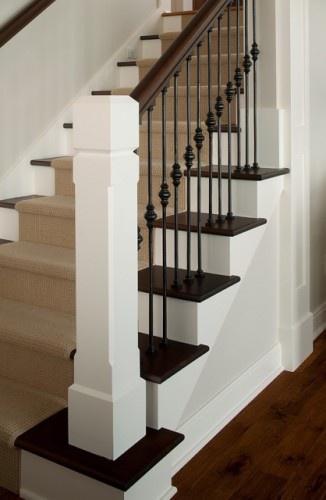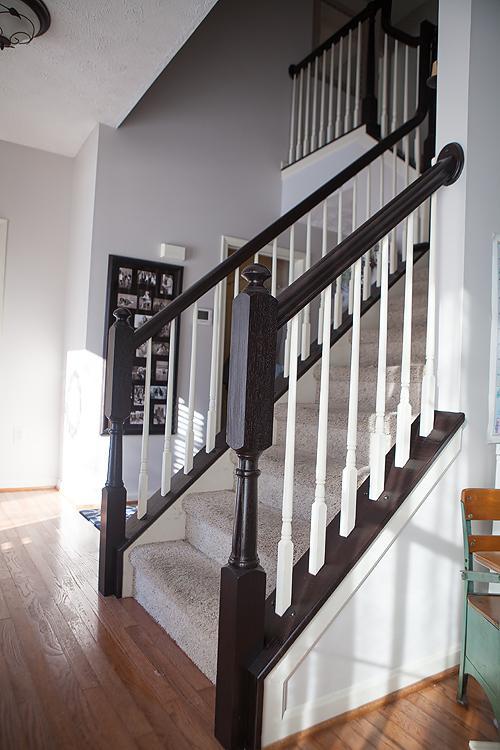The first image is the image on the left, the second image is the image on the right. Examine the images to the left and right. Is the description "In at least  one image there is a winding stair care that is both white and wood brown." accurate? Answer yes or no. No. 